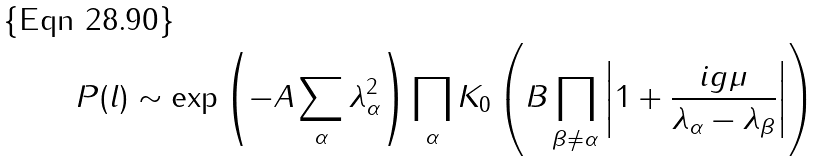<formula> <loc_0><loc_0><loc_500><loc_500>P ( l ) \sim \exp \left ( - A \sum _ { \alpha } \lambda _ { \alpha } ^ { 2 } \right ) \prod _ { \alpha } K _ { 0 } \left ( B \prod _ { \beta \neq \alpha } \left | 1 + \frac { i g \mu } { \lambda _ { \alpha } - \lambda _ { \beta } } \right | \right )</formula> 